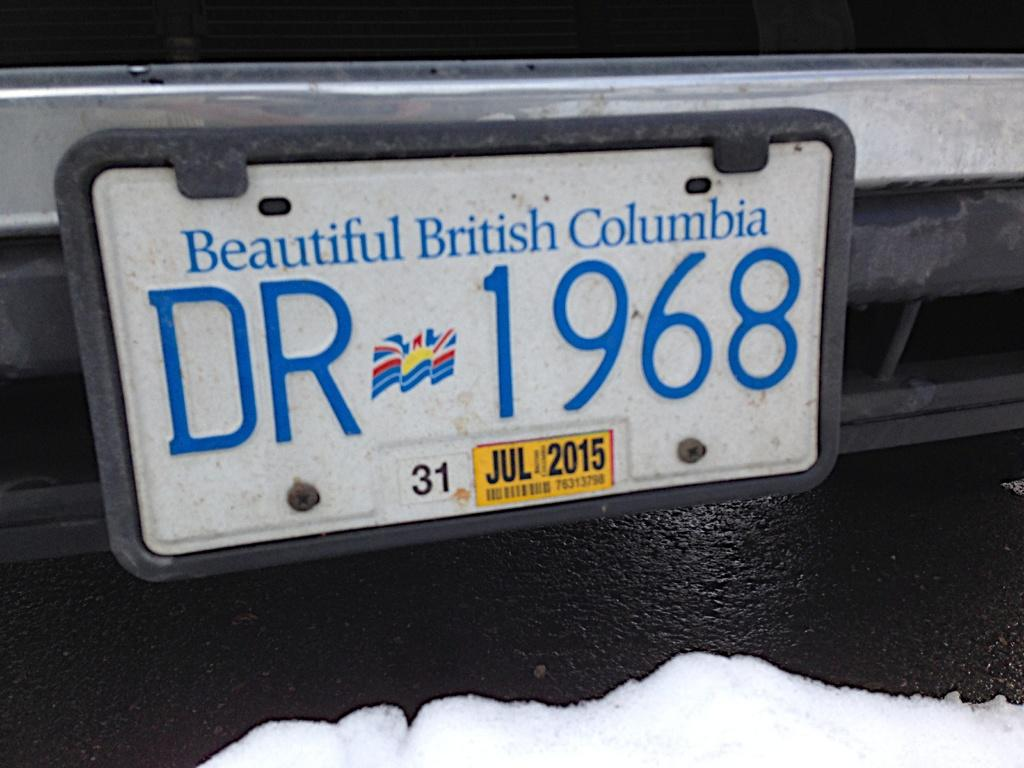<image>
Present a compact description of the photo's key features. White license plate for British columbia which says DR1968. 